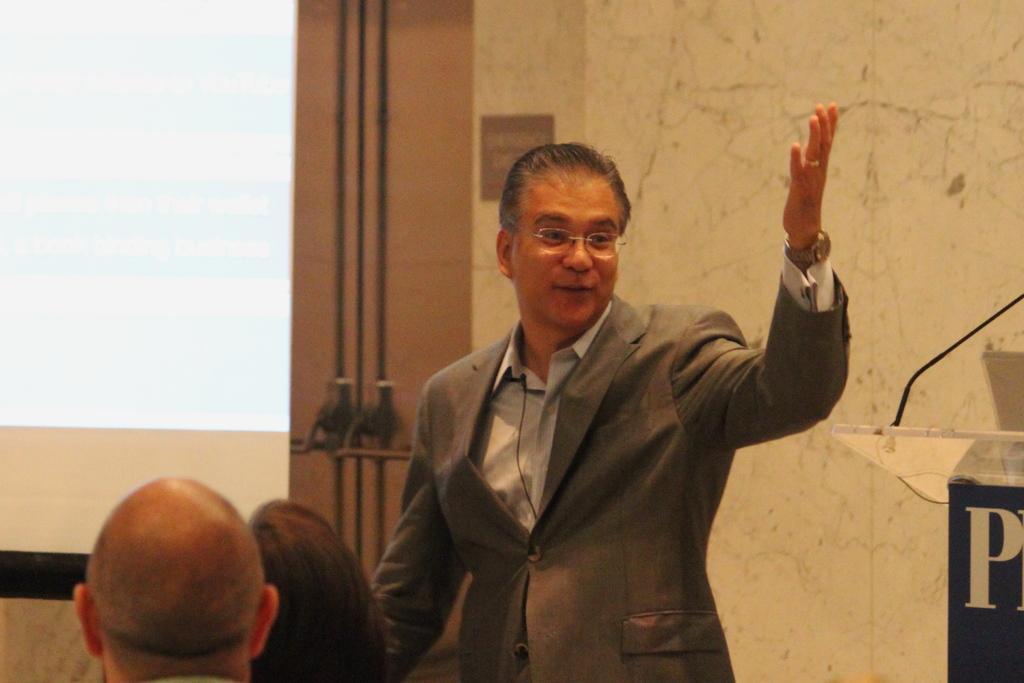Can you describe this image briefly? In this image there is a person standing, beside the person there is a table with a mic, in front of the person there are are two people sitting. In the background there is a screen and a wall. 